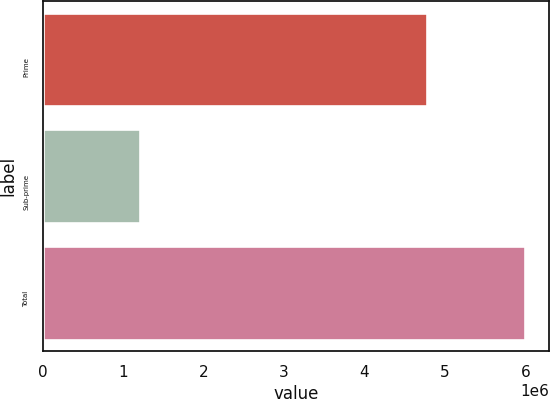Convert chart to OTSL. <chart><loc_0><loc_0><loc_500><loc_500><bar_chart><fcel>Prime<fcel>Sub-prime<fcel>Total<nl><fcel>4.77745e+06<fcel>1.21402e+06<fcel>5.99147e+06<nl></chart> 